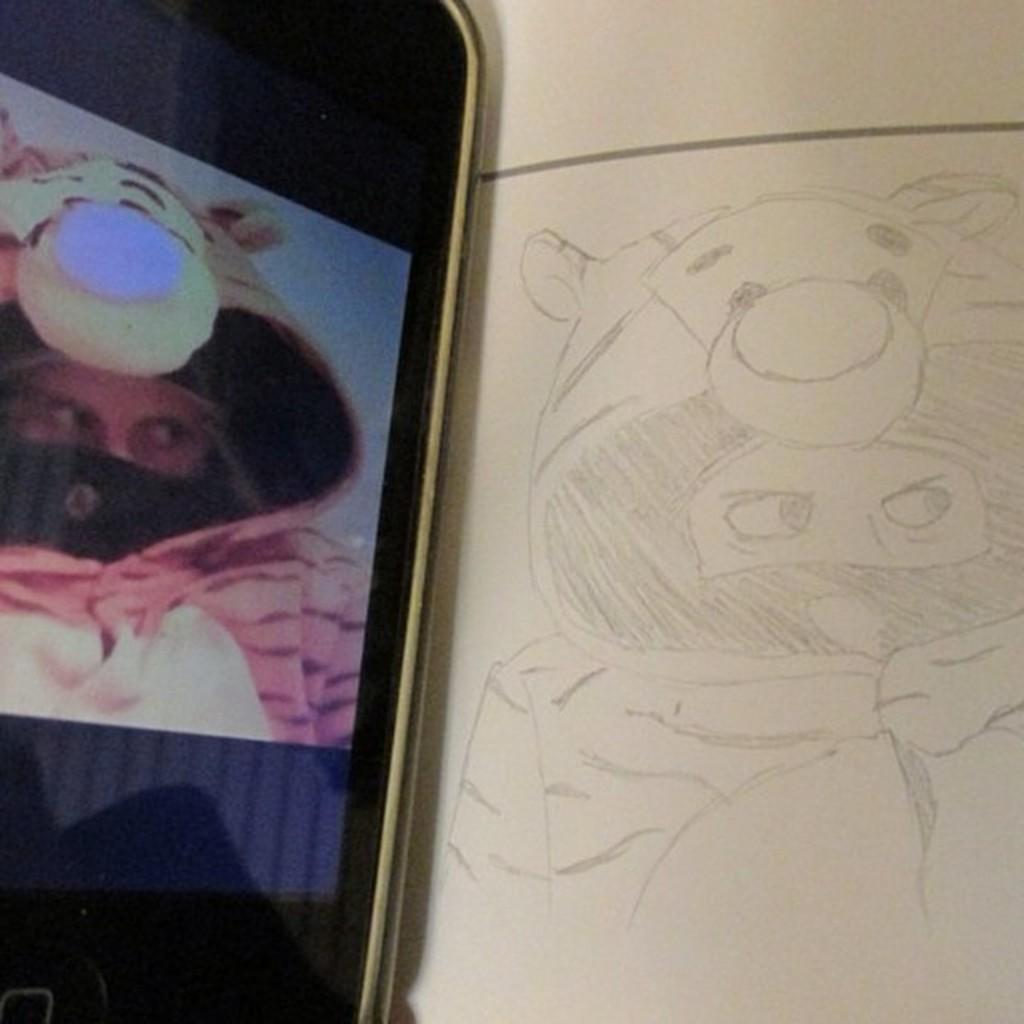How would you summarize this image in a sentence or two? In this image we can see a drawing of a person wearing a costume. On the mobile screen we can see a person wearing a costume at the left side of the image. 